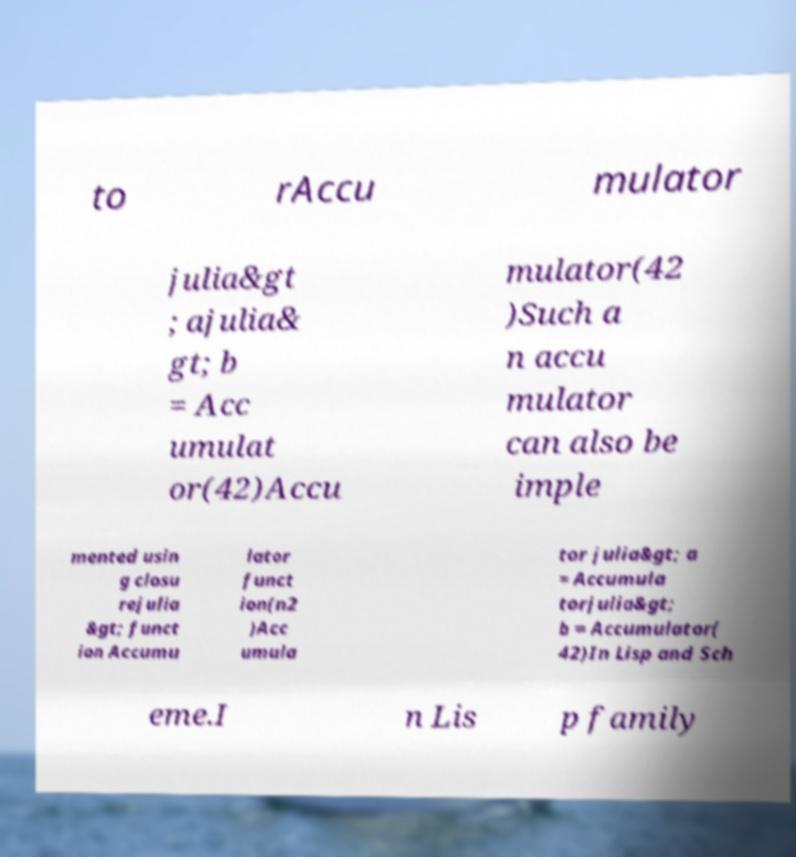Please read and relay the text visible in this image. What does it say? to rAccu mulator julia&gt ; ajulia& gt; b = Acc umulat or(42)Accu mulator(42 )Such a n accu mulator can also be imple mented usin g closu rejulia &gt; funct ion Accumu lator funct ion(n2 )Acc umula tor julia&gt; a = Accumula torjulia&gt; b = Accumulator( 42)In Lisp and Sch eme.I n Lis p family 